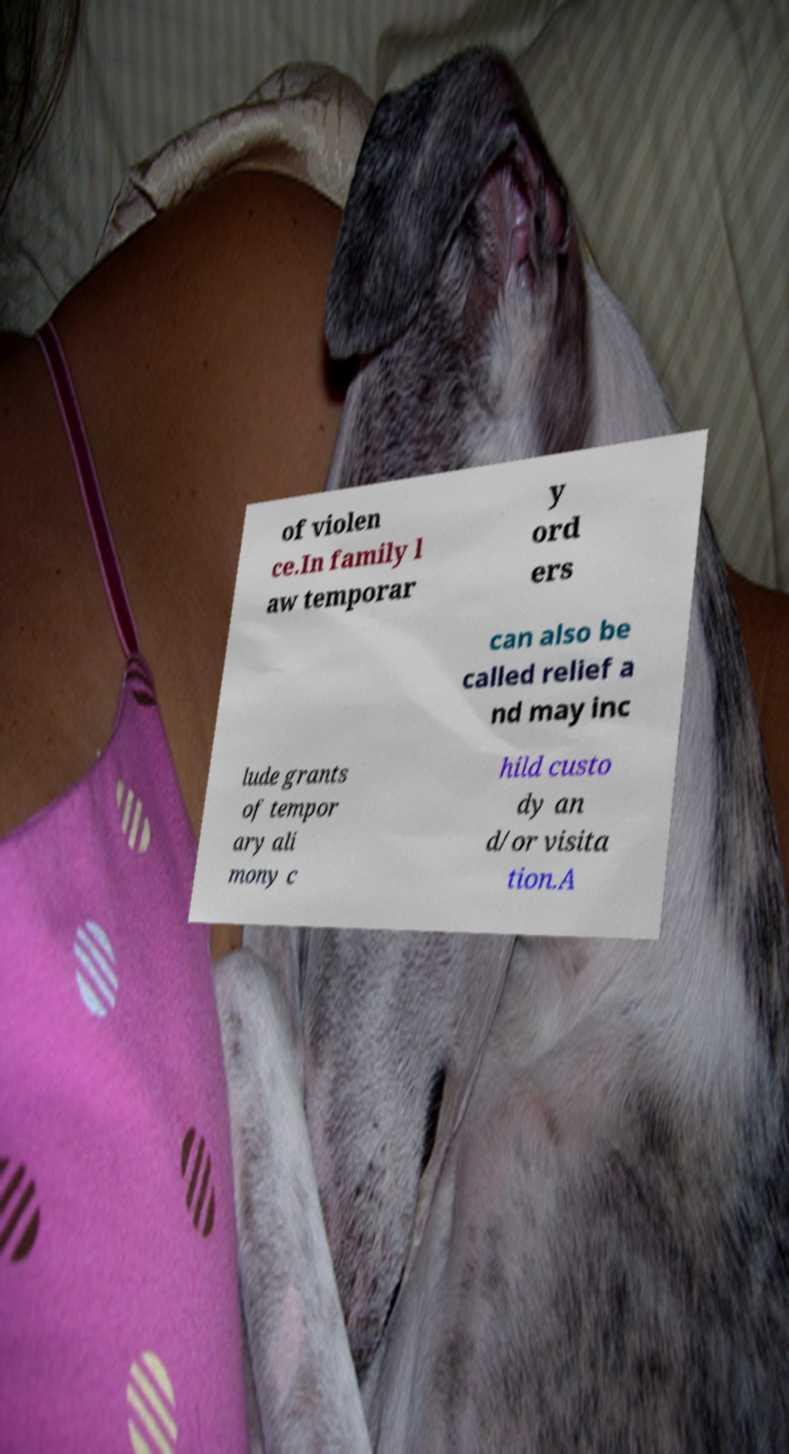What messages or text are displayed in this image? I need them in a readable, typed format. of violen ce.In family l aw temporar y ord ers can also be called relief a nd may inc lude grants of tempor ary ali mony c hild custo dy an d/or visita tion.A 